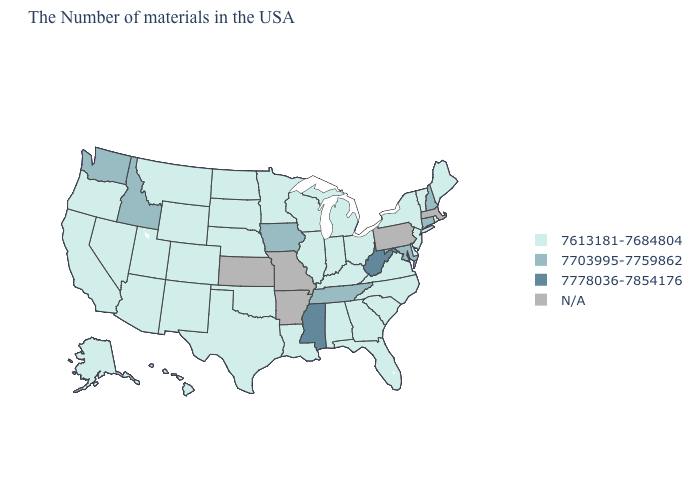What is the lowest value in the USA?
Answer briefly. 7613181-7684804. What is the highest value in the USA?
Concise answer only. 7778036-7854176. What is the highest value in the USA?
Short answer required. 7778036-7854176. What is the value of Kansas?
Write a very short answer. N/A. Does Iowa have the lowest value in the MidWest?
Answer briefly. No. Among the states that border South Dakota , does Iowa have the lowest value?
Answer briefly. No. Name the states that have a value in the range 7613181-7684804?
Quick response, please. Maine, Rhode Island, Vermont, New York, New Jersey, Delaware, Virginia, North Carolina, South Carolina, Ohio, Florida, Georgia, Michigan, Kentucky, Indiana, Alabama, Wisconsin, Illinois, Louisiana, Minnesota, Nebraska, Oklahoma, Texas, South Dakota, North Dakota, Wyoming, Colorado, New Mexico, Utah, Montana, Arizona, Nevada, California, Oregon, Alaska, Hawaii. Does Iowa have the highest value in the MidWest?
Short answer required. Yes. Does the map have missing data?
Quick response, please. Yes. What is the value of Massachusetts?
Answer briefly. N/A. What is the value of Alabama?
Answer briefly. 7613181-7684804. Which states hav the highest value in the West?
Short answer required. Idaho, Washington. What is the value of Michigan?
Be succinct. 7613181-7684804. Name the states that have a value in the range 7613181-7684804?
Quick response, please. Maine, Rhode Island, Vermont, New York, New Jersey, Delaware, Virginia, North Carolina, South Carolina, Ohio, Florida, Georgia, Michigan, Kentucky, Indiana, Alabama, Wisconsin, Illinois, Louisiana, Minnesota, Nebraska, Oklahoma, Texas, South Dakota, North Dakota, Wyoming, Colorado, New Mexico, Utah, Montana, Arizona, Nevada, California, Oregon, Alaska, Hawaii. 